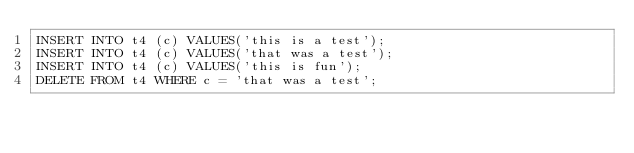Convert code to text. <code><loc_0><loc_0><loc_500><loc_500><_SQL_>INSERT INTO t4 (c) VALUES('this is a test');
INSERT INTO t4 (c) VALUES('that was a test');
INSERT INTO t4 (c) VALUES('this is fun');
DELETE FROM t4 WHERE c = 'that was a test';</code> 